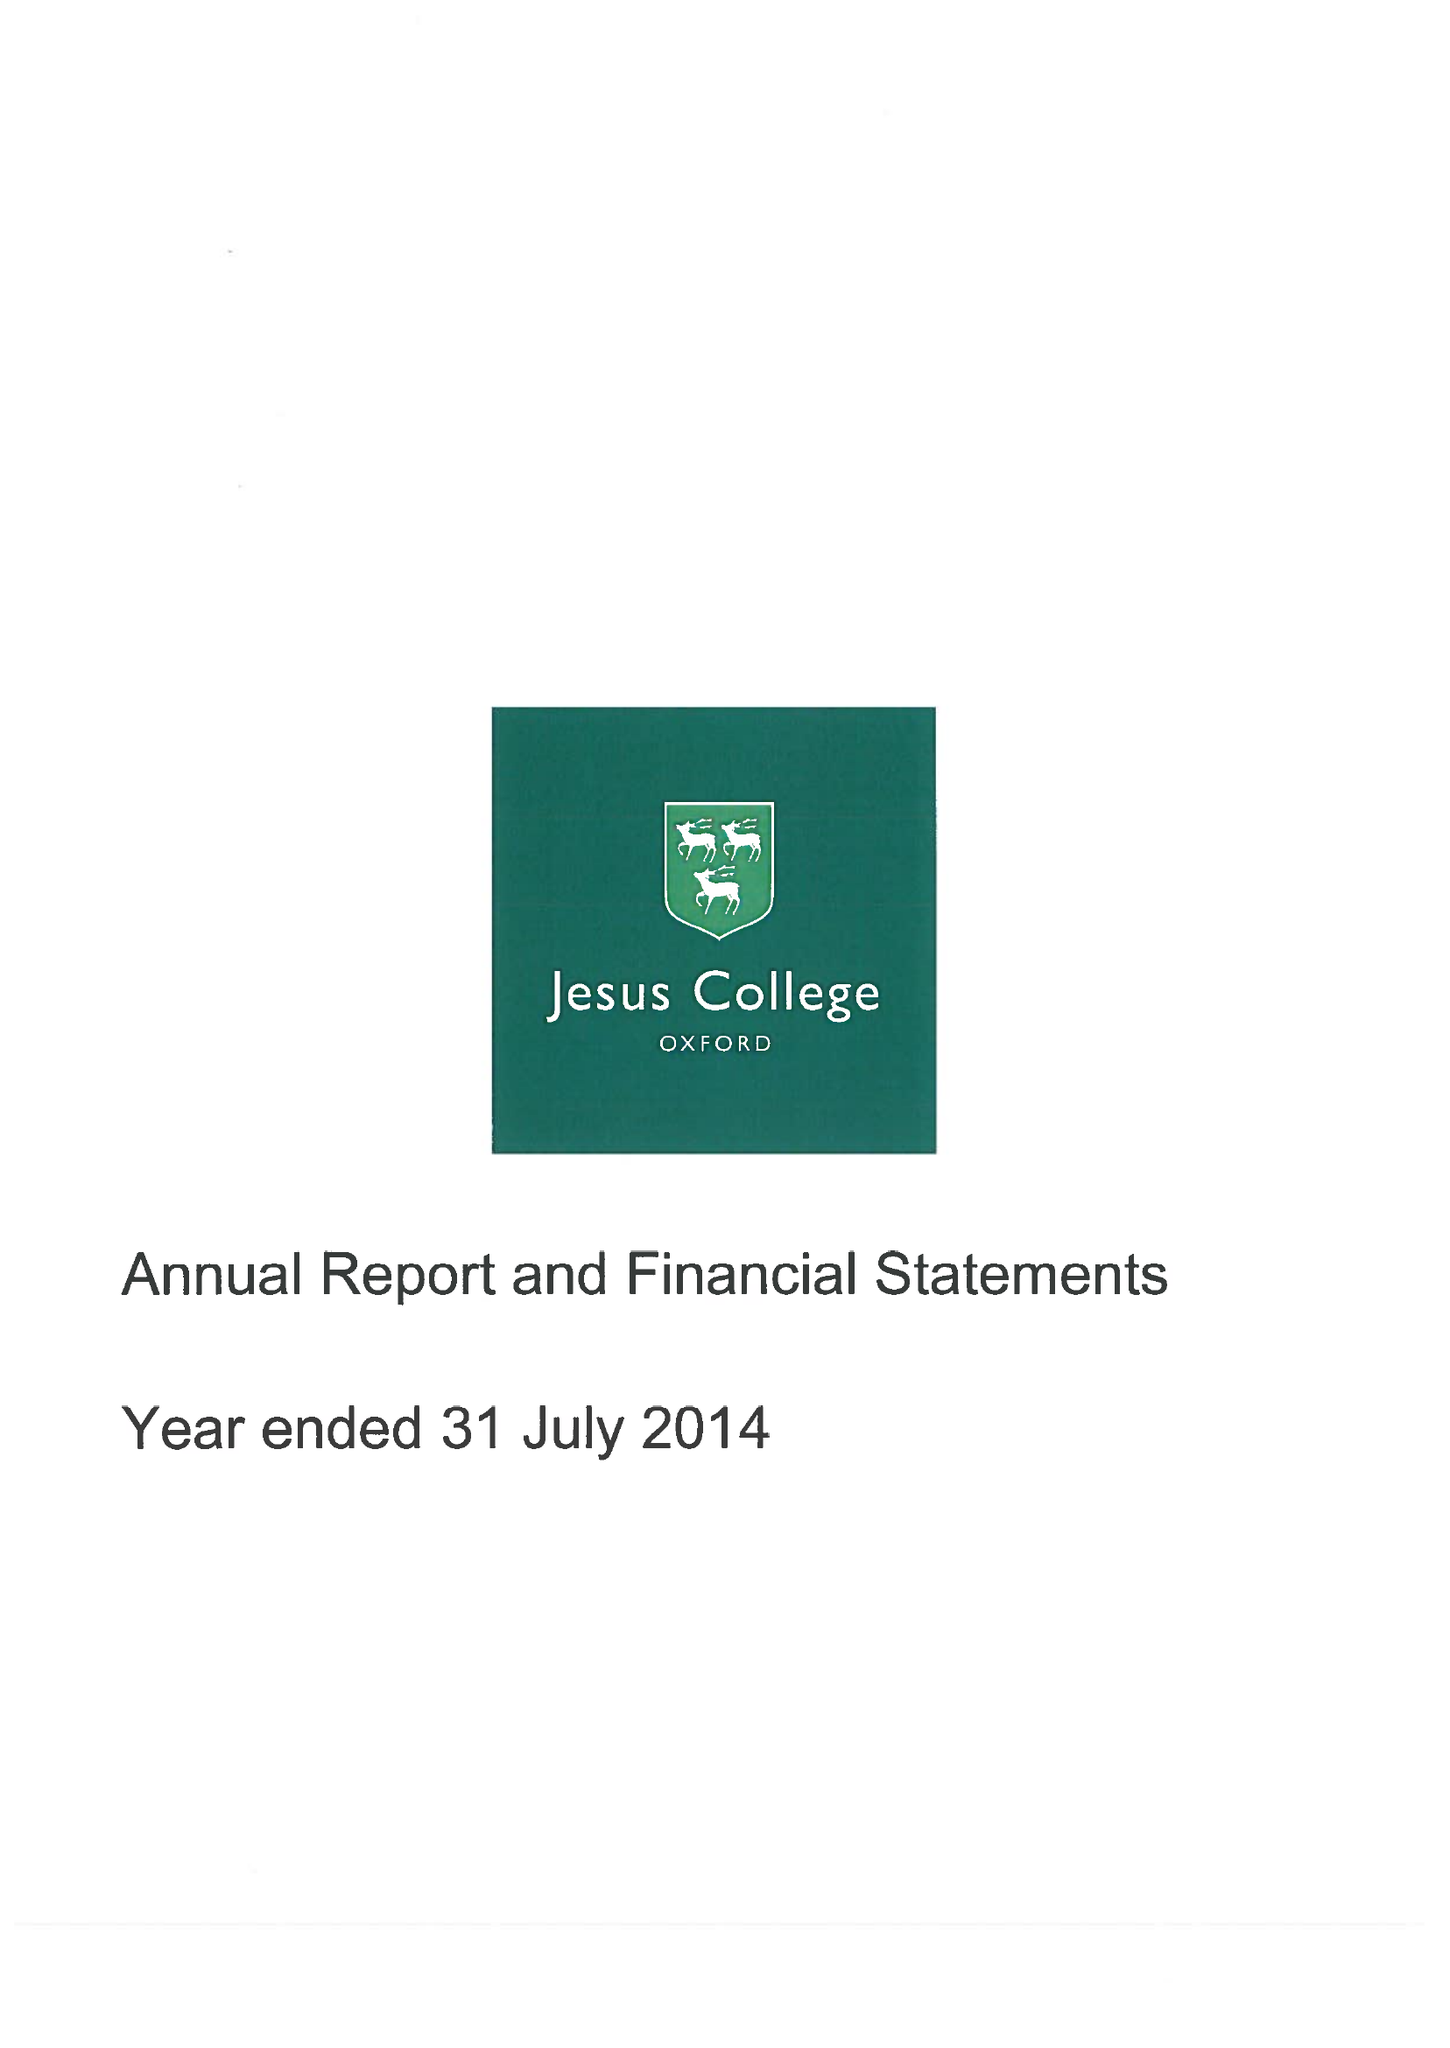What is the value for the charity_name?
Answer the question using a single word or phrase. Jesus College Within The University and City Of Oxford Of Queen Elizabeth's Foundation 